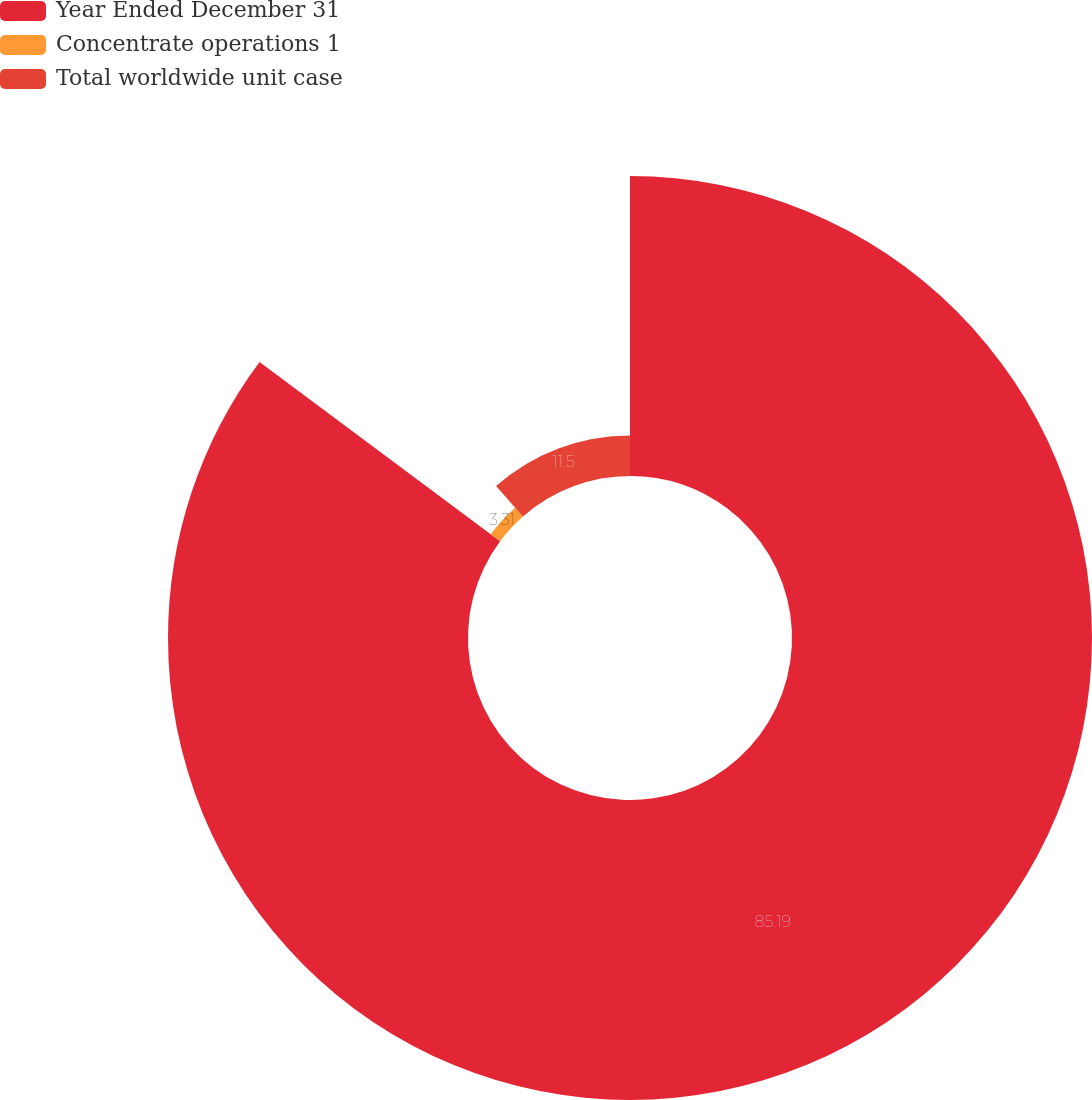Convert chart. <chart><loc_0><loc_0><loc_500><loc_500><pie_chart><fcel>Year Ended December 31<fcel>Concentrate operations 1<fcel>Total worldwide unit case<nl><fcel>85.2%<fcel>3.31%<fcel>11.5%<nl></chart> 